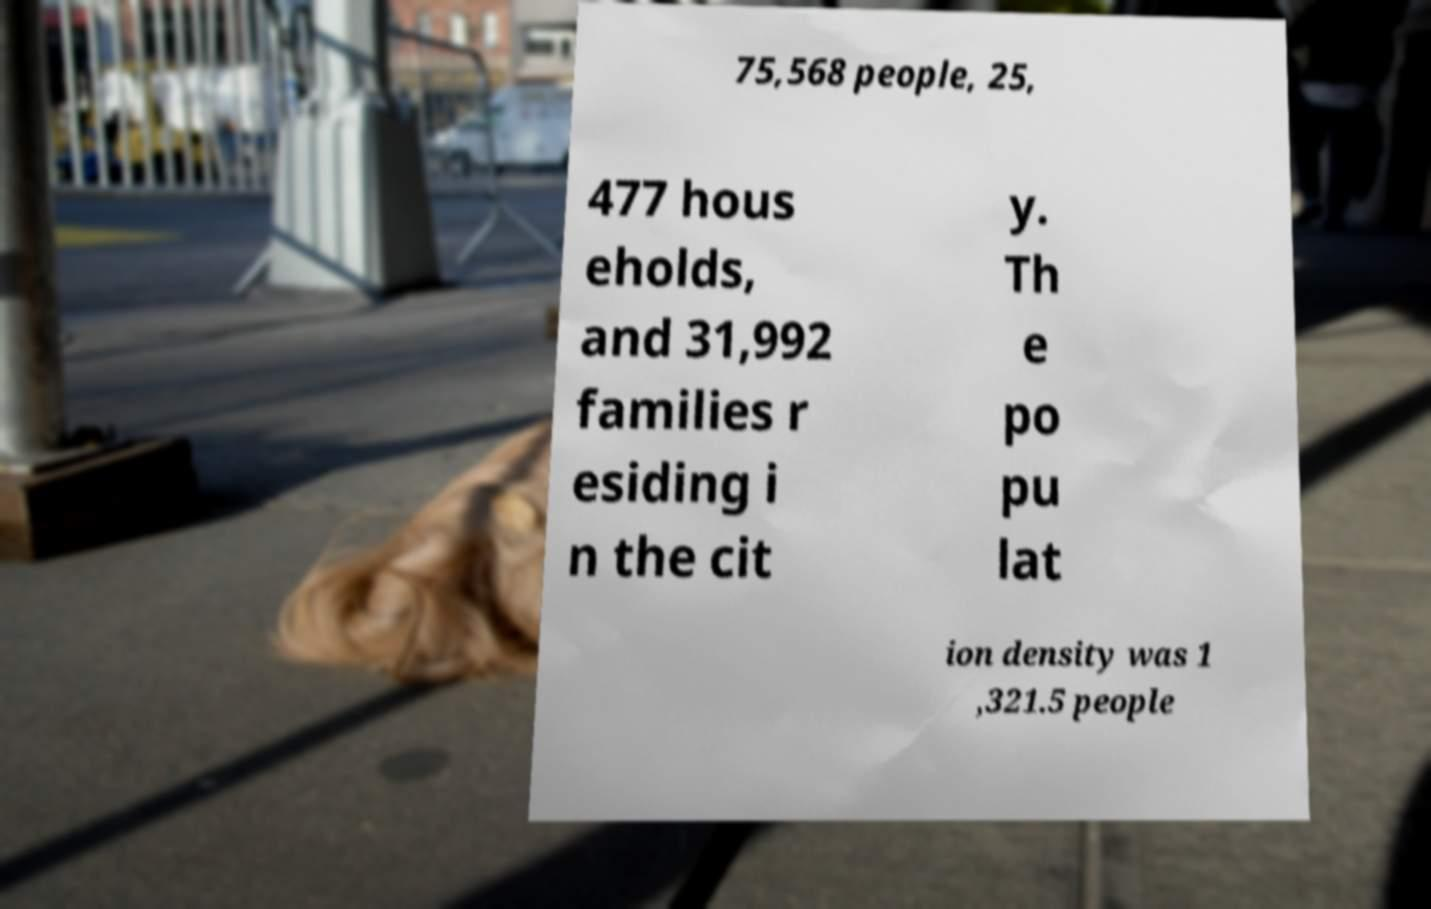Could you extract and type out the text from this image? 75,568 people, 25, 477 hous eholds, and 31,992 families r esiding i n the cit y. Th e po pu lat ion density was 1 ,321.5 people 